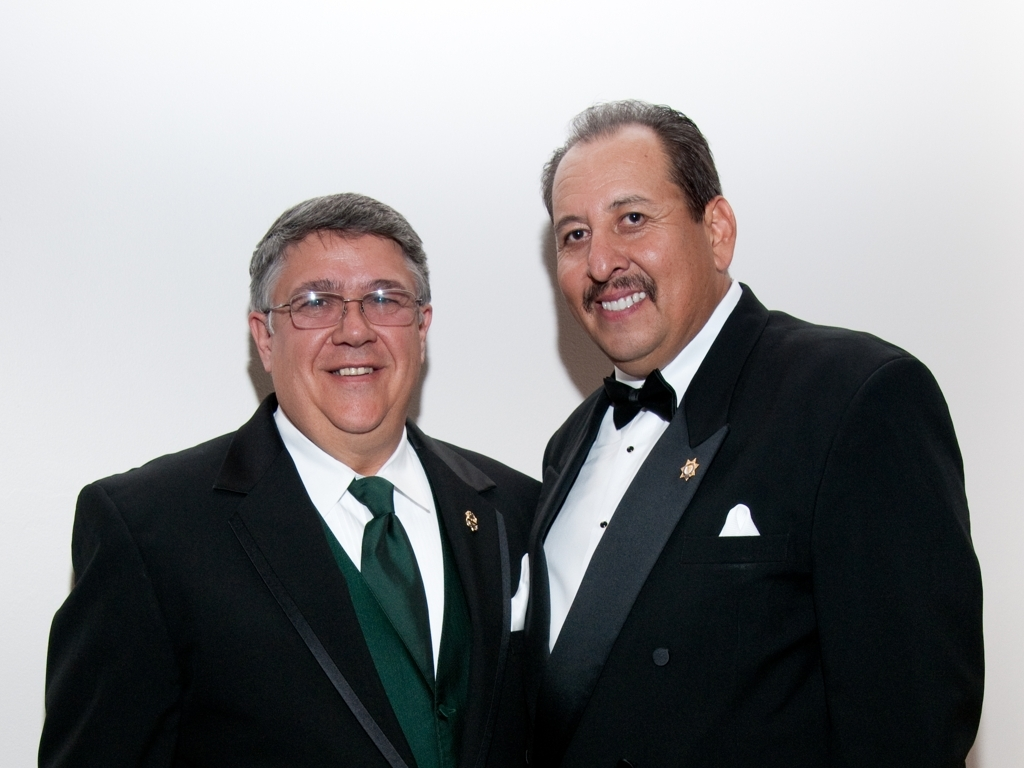What might be the occasion for them dressing up like this? Given their formal attire, it's likely that the two individuals are attending a special event such as a gala, an award ceremony, a wedding, or a formal dinner. The elegance of their outfits suggests a sophisticated and possibly celebratory gathering. 